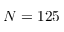<formula> <loc_0><loc_0><loc_500><loc_500>N = 1 2 5</formula> 